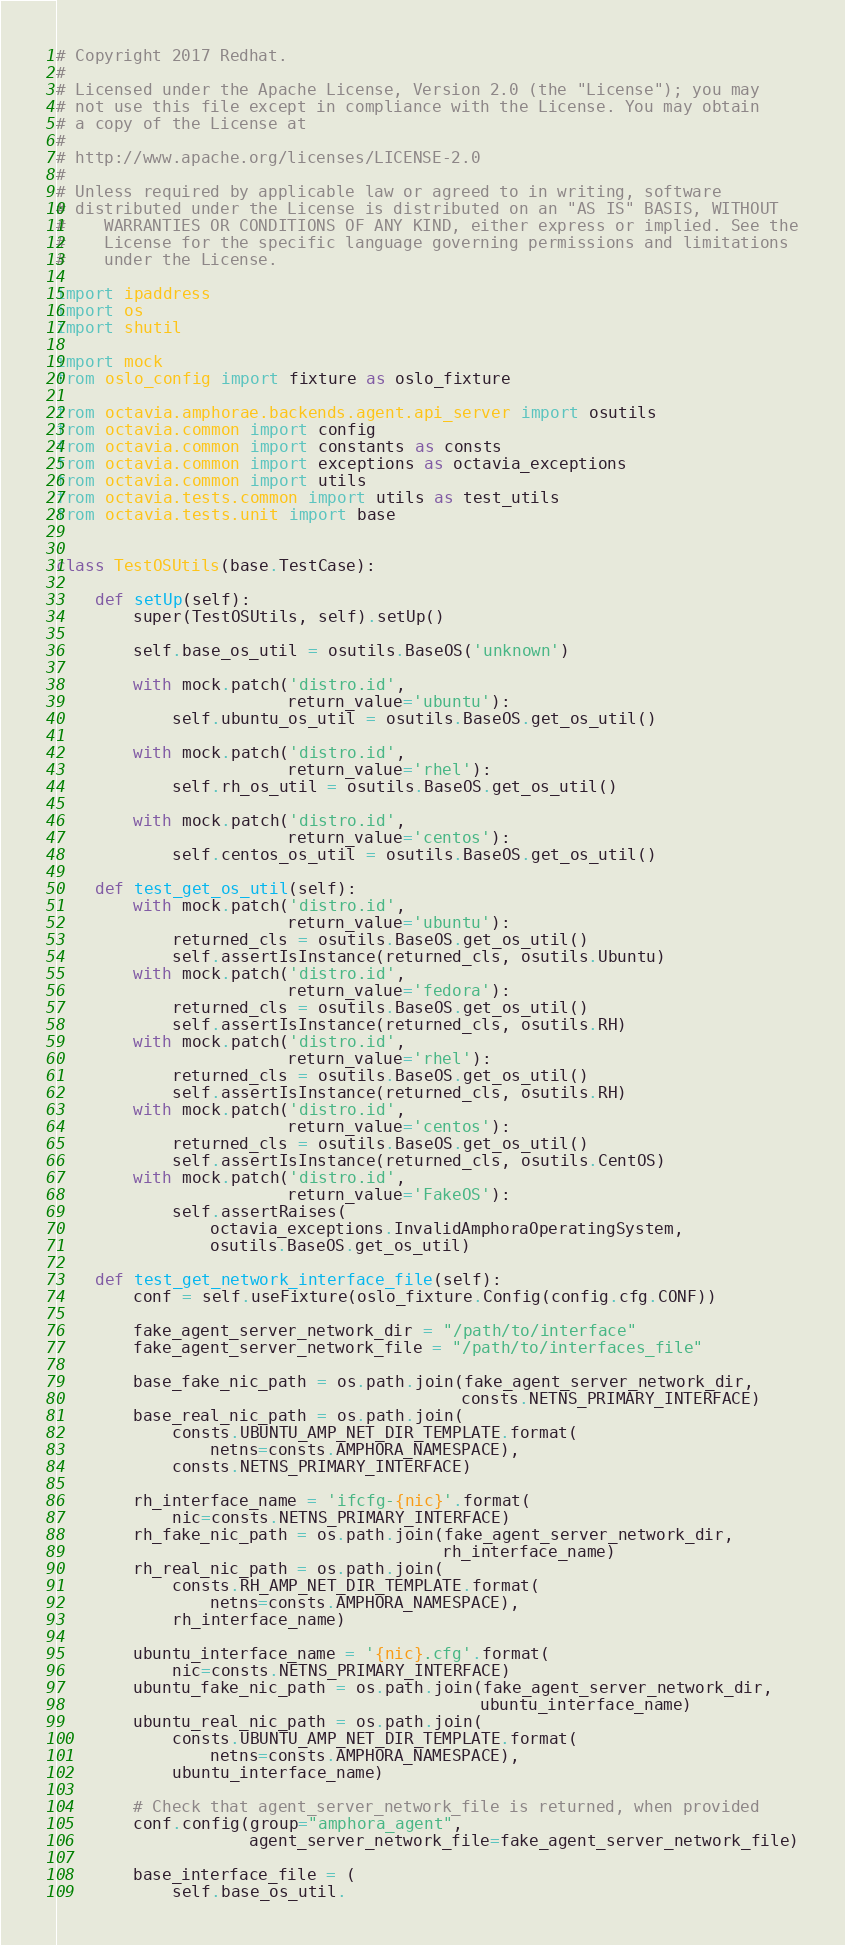<code> <loc_0><loc_0><loc_500><loc_500><_Python_># Copyright 2017 Redhat.
#
# Licensed under the Apache License, Version 2.0 (the "License"); you may
# not use this file except in compliance with the License. You may obtain
# a copy of the License at
#
# http://www.apache.org/licenses/LICENSE-2.0
#
# Unless required by applicable law or agreed to in writing, software
# distributed under the License is distributed on an "AS IS" BASIS, WITHOUT
#    WARRANTIES OR CONDITIONS OF ANY KIND, either express or implied. See the
#    License for the specific language governing permissions and limitations
#    under the License.

import ipaddress
import os
import shutil

import mock
from oslo_config import fixture as oslo_fixture

from octavia.amphorae.backends.agent.api_server import osutils
from octavia.common import config
from octavia.common import constants as consts
from octavia.common import exceptions as octavia_exceptions
from octavia.common import utils
from octavia.tests.common import utils as test_utils
from octavia.tests.unit import base


class TestOSUtils(base.TestCase):

    def setUp(self):
        super(TestOSUtils, self).setUp()

        self.base_os_util = osutils.BaseOS('unknown')

        with mock.patch('distro.id',
                        return_value='ubuntu'):
            self.ubuntu_os_util = osutils.BaseOS.get_os_util()

        with mock.patch('distro.id',
                        return_value='rhel'):
            self.rh_os_util = osutils.BaseOS.get_os_util()

        with mock.patch('distro.id',
                        return_value='centos'):
            self.centos_os_util = osutils.BaseOS.get_os_util()

    def test_get_os_util(self):
        with mock.patch('distro.id',
                        return_value='ubuntu'):
            returned_cls = osutils.BaseOS.get_os_util()
            self.assertIsInstance(returned_cls, osutils.Ubuntu)
        with mock.patch('distro.id',
                        return_value='fedora'):
            returned_cls = osutils.BaseOS.get_os_util()
            self.assertIsInstance(returned_cls, osutils.RH)
        with mock.patch('distro.id',
                        return_value='rhel'):
            returned_cls = osutils.BaseOS.get_os_util()
            self.assertIsInstance(returned_cls, osutils.RH)
        with mock.patch('distro.id',
                        return_value='centos'):
            returned_cls = osutils.BaseOS.get_os_util()
            self.assertIsInstance(returned_cls, osutils.CentOS)
        with mock.patch('distro.id',
                        return_value='FakeOS'):
            self.assertRaises(
                octavia_exceptions.InvalidAmphoraOperatingSystem,
                osutils.BaseOS.get_os_util)

    def test_get_network_interface_file(self):
        conf = self.useFixture(oslo_fixture.Config(config.cfg.CONF))

        fake_agent_server_network_dir = "/path/to/interface"
        fake_agent_server_network_file = "/path/to/interfaces_file"

        base_fake_nic_path = os.path.join(fake_agent_server_network_dir,
                                          consts.NETNS_PRIMARY_INTERFACE)
        base_real_nic_path = os.path.join(
            consts.UBUNTU_AMP_NET_DIR_TEMPLATE.format(
                netns=consts.AMPHORA_NAMESPACE),
            consts.NETNS_PRIMARY_INTERFACE)

        rh_interface_name = 'ifcfg-{nic}'.format(
            nic=consts.NETNS_PRIMARY_INTERFACE)
        rh_fake_nic_path = os.path.join(fake_agent_server_network_dir,
                                        rh_interface_name)
        rh_real_nic_path = os.path.join(
            consts.RH_AMP_NET_DIR_TEMPLATE.format(
                netns=consts.AMPHORA_NAMESPACE),
            rh_interface_name)

        ubuntu_interface_name = '{nic}.cfg'.format(
            nic=consts.NETNS_PRIMARY_INTERFACE)
        ubuntu_fake_nic_path = os.path.join(fake_agent_server_network_dir,
                                            ubuntu_interface_name)
        ubuntu_real_nic_path = os.path.join(
            consts.UBUNTU_AMP_NET_DIR_TEMPLATE.format(
                netns=consts.AMPHORA_NAMESPACE),
            ubuntu_interface_name)

        # Check that agent_server_network_file is returned, when provided
        conf.config(group="amphora_agent",
                    agent_server_network_file=fake_agent_server_network_file)

        base_interface_file = (
            self.base_os_util.</code> 